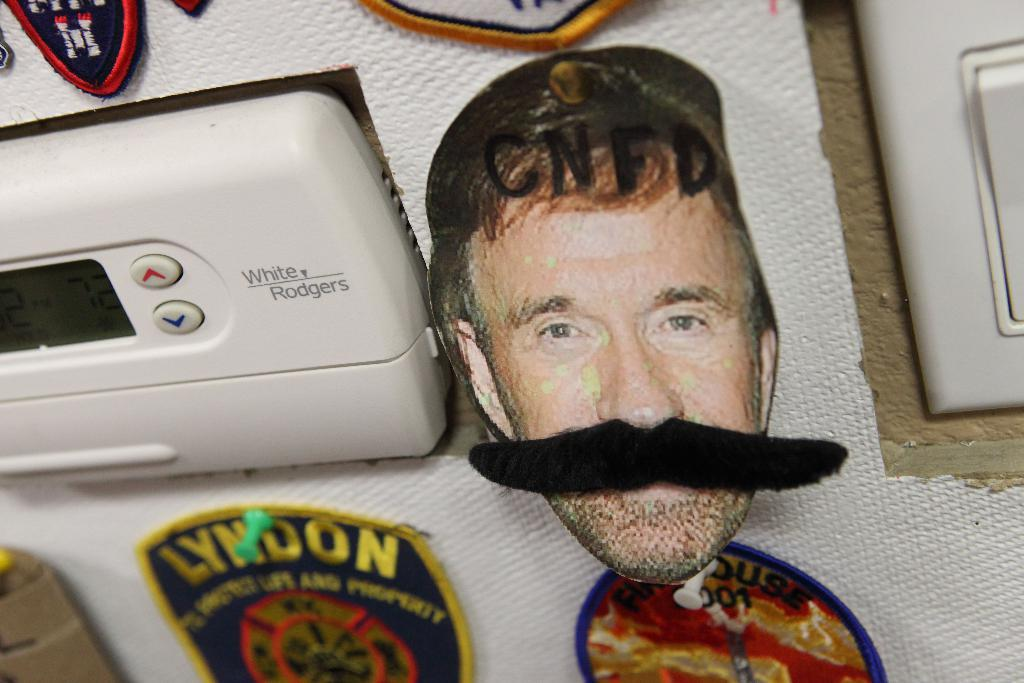Provide a one-sentence caption for the provided image. A picture of a man with a fake mustache on a bulletin board next to a White Rodgers thermostat. 